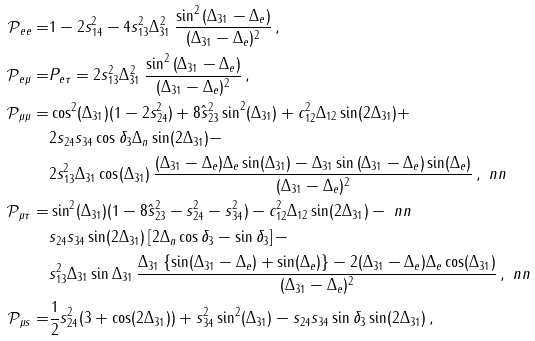Convert formula to latex. <formula><loc_0><loc_0><loc_500><loc_500>\mathcal { P } _ { e e } = & 1 - 2 s _ { 1 4 } ^ { 2 } - 4 s _ { 1 3 } ^ { 2 } \Delta _ { 3 1 } ^ { 2 } \, \frac { \sin ^ { 2 } \left ( \Delta _ { 3 1 } - \Delta _ { e } \right ) } { ( \Delta _ { 3 1 } - \Delta _ { e } ) ^ { 2 } } \, , \\ \mathcal { P } _ { e \mu } = & P _ { e \tau } = 2 s _ { 1 3 } ^ { 2 } \Delta _ { 3 1 } ^ { 2 } \, \frac { \sin ^ { 2 } \left ( \Delta _ { 3 1 } - \Delta _ { e } \right ) } { ( \Delta _ { 3 1 } - \Delta _ { e } ) ^ { 2 } } \, , \\ \mathcal { P } _ { \mu \mu } = & \cos ^ { 2 } ( \Delta _ { 3 1 } ) ( 1 - 2 s _ { 2 4 } ^ { 2 } ) + 8 \hat { s } _ { 2 3 } ^ { 2 } \sin ^ { 2 } ( \Delta _ { 3 1 } ) + c _ { 1 2 } ^ { 2 } \Delta _ { 1 2 } \sin ( 2 \Delta _ { 3 1 } ) + \\ & 2 s _ { 2 4 } s _ { 3 4 } \cos \delta _ { 3 } \Delta _ { n } \sin ( 2 \Delta _ { 3 1 } ) - \\ & 2 s _ { 1 3 } ^ { 2 } \Delta _ { 3 1 } \cos ( \Delta _ { 3 1 } ) \, \frac { ( \Delta _ { 3 1 } - \Delta _ { e } ) \Delta _ { e } \sin ( \Delta _ { 3 1 } ) - \Delta _ { 3 1 } \sin \left ( \Delta _ { 3 1 } - \Delta _ { e } \right ) \sin ( \Delta _ { e } ) } { ( \Delta _ { 3 1 } - \Delta _ { e } ) ^ { 2 } } \, , \ n n \\ \mathcal { P } _ { \mu \tau } = & \sin ^ { 2 } ( \Delta _ { 3 1 } ) ( 1 - 8 \hat { s } _ { 2 3 } ^ { 2 } - s _ { 2 4 } ^ { 2 } - s _ { 3 4 } ^ { 2 } ) - c _ { 1 2 } ^ { 2 } \Delta _ { 1 2 } \sin ( 2 \Delta _ { 3 1 } ) - \ n n \\ & s _ { 2 4 } s _ { 3 4 } \sin ( 2 \Delta _ { 3 1 } ) \left [ 2 \Delta _ { n } \cos \delta _ { 3 } - \sin \delta _ { 3 } \right ] - \\ & s _ { 1 3 } ^ { 2 } \Delta _ { 3 1 } \sin \Delta _ { 3 1 } \, \frac { \Delta _ { 3 1 } \left \{ \sin ( \Delta _ { 3 1 } - \Delta _ { e } ) + \sin ( \Delta _ { e } ) \right \} - 2 ( \Delta _ { 3 1 } - \Delta _ { e } ) \Delta _ { e } \cos ( \Delta _ { 3 1 } ) } { ( \Delta _ { 3 1 } - \Delta _ { e } ) ^ { 2 } } \, , \ n n \\ \mathcal { P } _ { \mu s } = & \frac { 1 } { 2 } s _ { 2 4 } ^ { 2 } ( 3 + \cos ( 2 \Delta _ { 3 1 } ) ) + s _ { 3 4 } ^ { 2 } \sin ^ { 2 } ( \Delta _ { 3 1 } ) - s _ { 2 4 } s _ { 3 4 } \sin \delta _ { 3 } \sin ( 2 \Delta _ { 3 1 } ) \, ,</formula> 